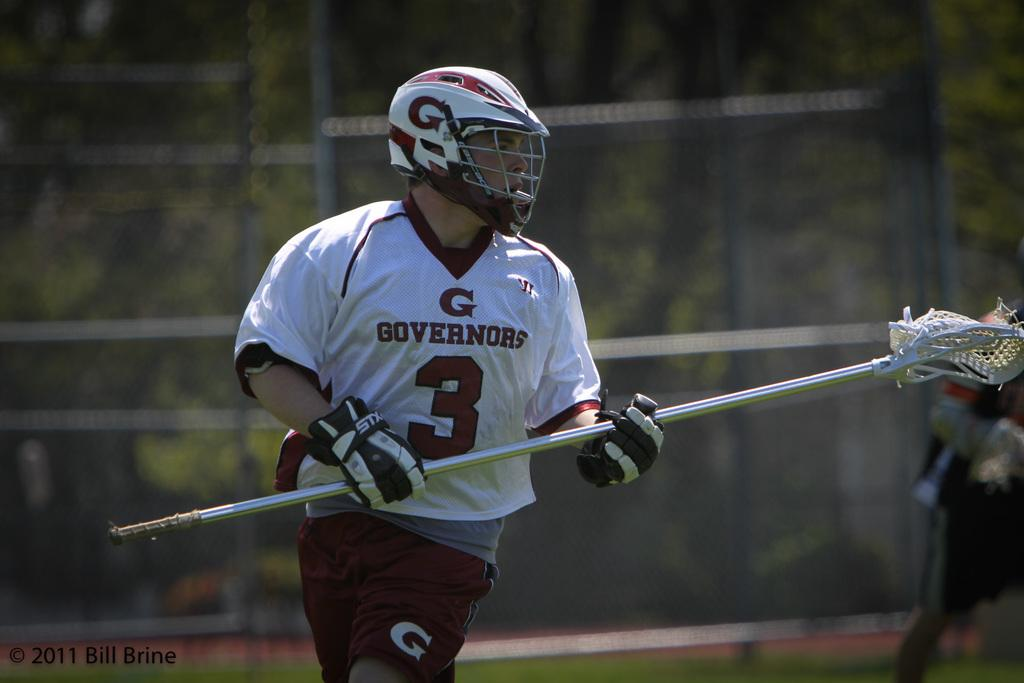What is the main subject of the image? There is a person standing in the center of the image. What is the person holding in the image? The person is holding an object. What type of protective gear is the person wearing? The person is wearing a helmet and gloves. What can be seen in the background of the image? There is a fence visible in the background of the image. What type of behavior can be observed in the pail in the image? There is no pail present in the image, so no behavior can be observed in a pail. 